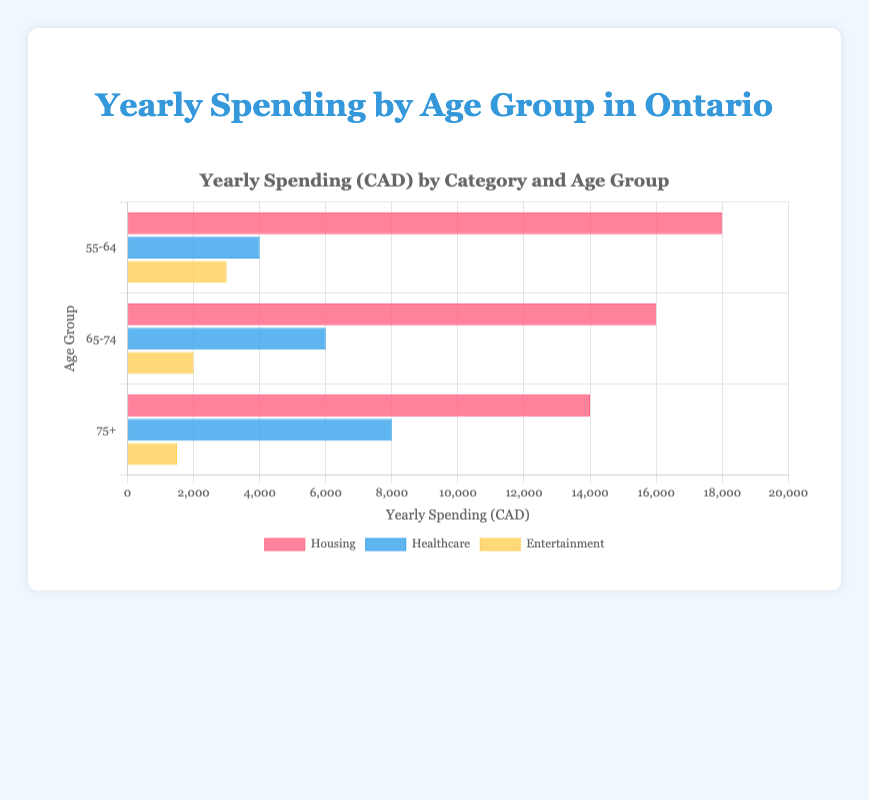What age group spends the most on housing each year? The bar for the "55-64" age group under the "Housing" category is the longest, indicating the highest spending.
Answer: 55-64 What is the total yearly spending on healthcare for all age groups combined? Add the healthcare spending for each age group: 4000 (55-64) + 6000 (65-74) + 8000 (75+). The total is 18000.
Answer: 18000 How does the yearly spending on entertainment for the 75+ age group compare to the 55-64 age group? Compare the bar lengths for "Entertainment" under "75+" and "55-64" groups. The spending is 1500 for 75+ and 3000 for 55-64, so 75+ spends less.
Answer: Less What is the average yearly spending on housing for all age groups? Calculate (18000 + 16000 + 14000) / 3. The total is 48000, so the average is 48000/3 = 16000.
Answer: 16000 Which category sees an increase in spending as age increases? Compare the lengths of bars for each category across age groups. "Healthcare" spending increases from 4000 to 6000 to 8000.
Answer: Healthcare How much more is the healthcare spending for the 75+ age group compared to the 55-64 age group? Subtract the healthcare spending of the "55-64" age group from the "75+" age group: 8000 - 4000 = 4000.
Answer: 4000 Which age group spends the least on entertainment? The shortest bar under the "Entertainment" category is for the "75+" age group.
Answer: 75+ What's the difference between the highest and lowest spending categories for the "65-74" age group? Subtract the lowest spending (2000 on entertainment) from the highest spending (16000 on housing): 16000 - 2000 = 14000.
Answer: 14000 Which category do all age groups consistently spend the most on? The bars for "Housing" are longest across all age groups when compared to other categories.
Answer: Housing How does the yearly spending on housing for the 75+ age group compare to the 65-74 age group? Compare the bar lengths for "Housing" under "75+" and "65-74" groups. The spending is 14000 for 75+ and 16000 for 65-74, so 75+ spends less.
Answer: Less 